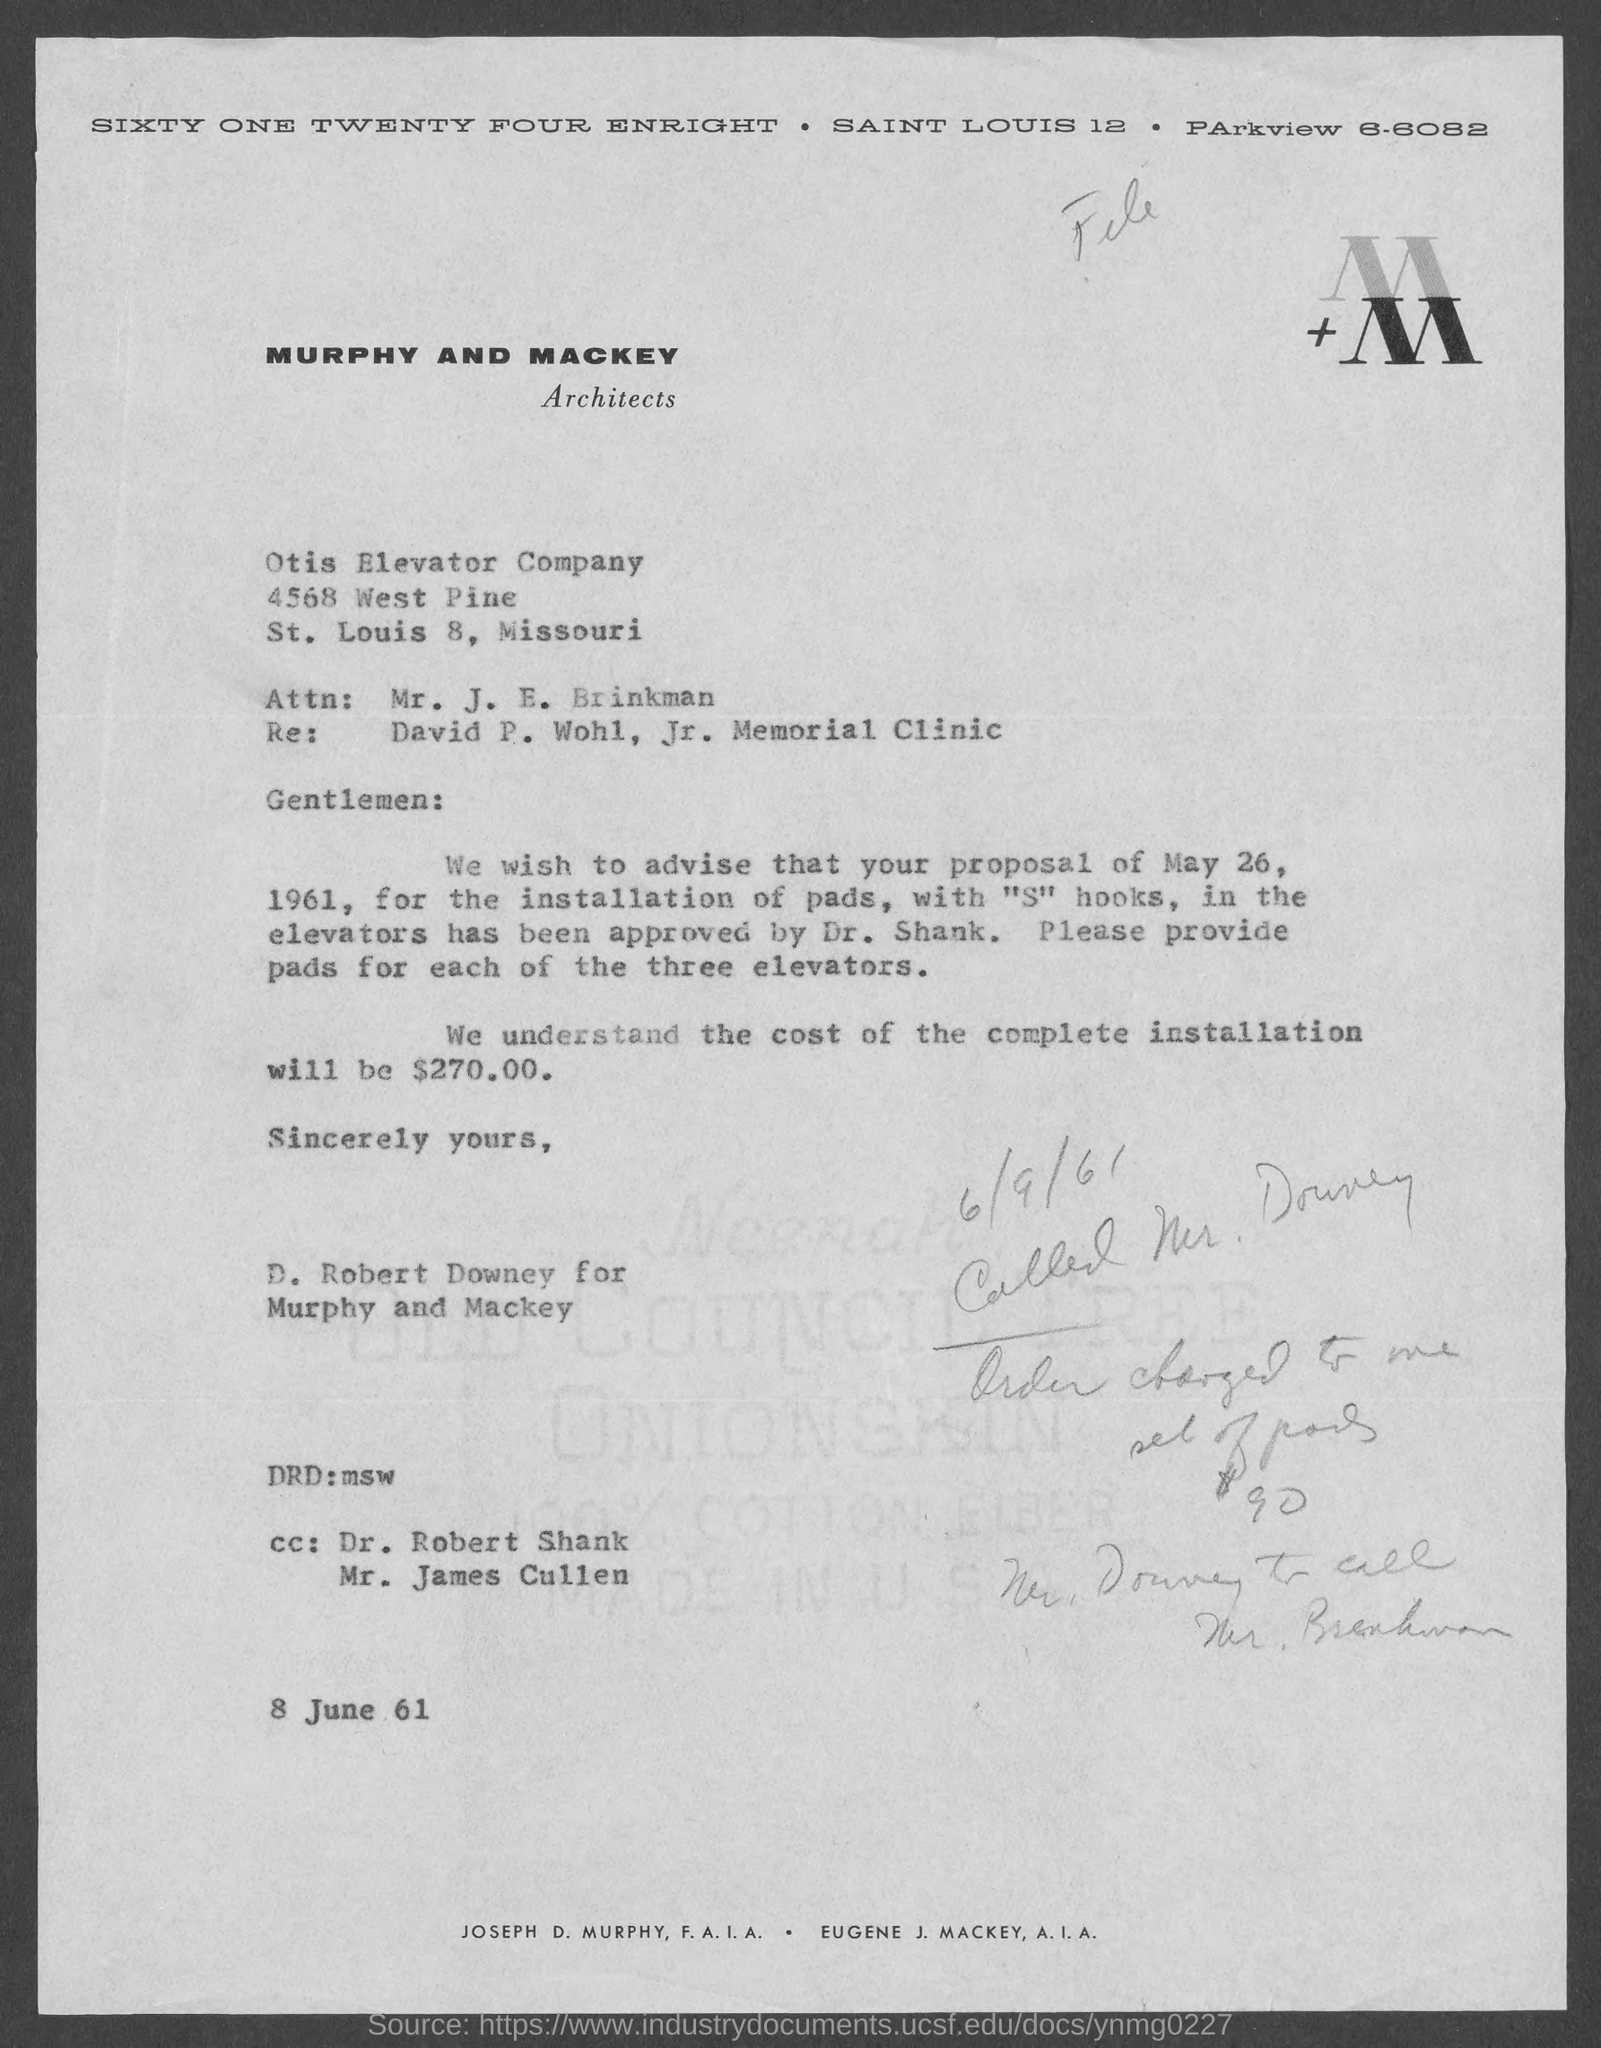Which is the architects mentioned in the letterhead?
Your answer should be very brief. MURPHY AND MACKEY. Who approved the proposal for the installation of pads with "S" hooks?
Make the answer very short. Dr. Shank. How much is the total cost of complete installation of pads?
Keep it short and to the point. $270.00. 